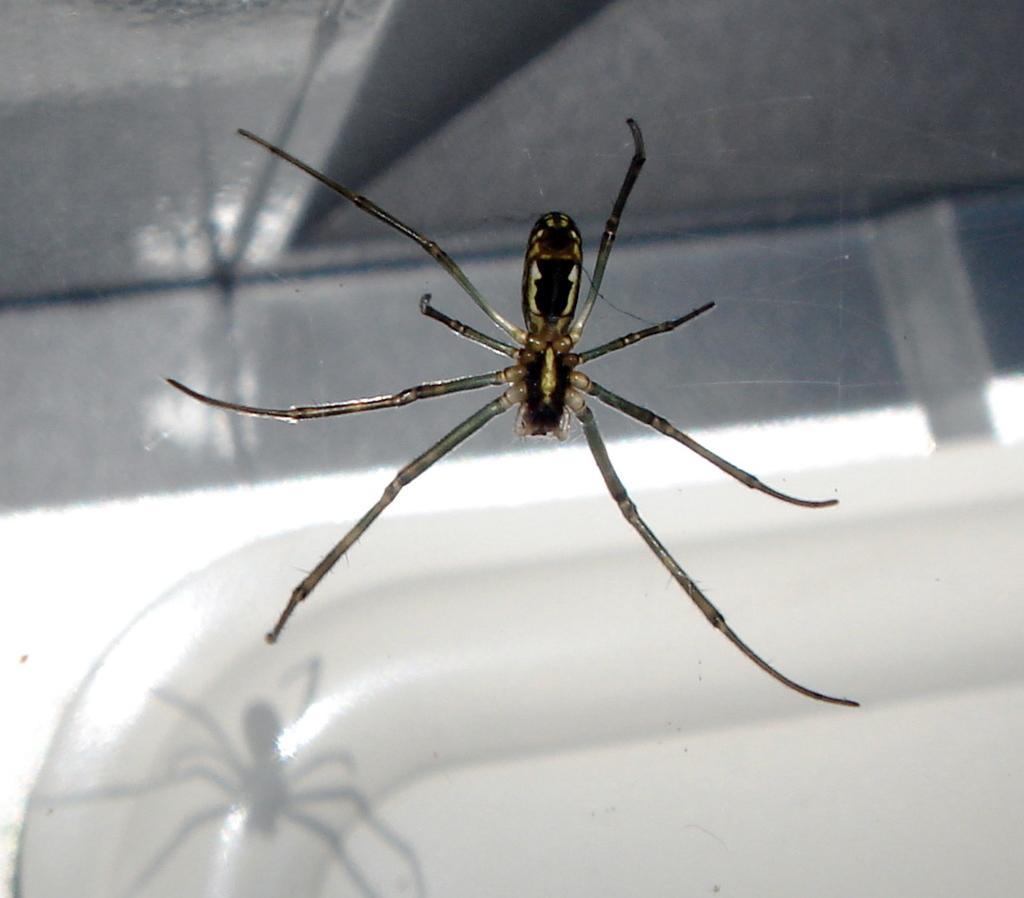Describe this image in one or two sentences. In this image in the front there is a spider. 